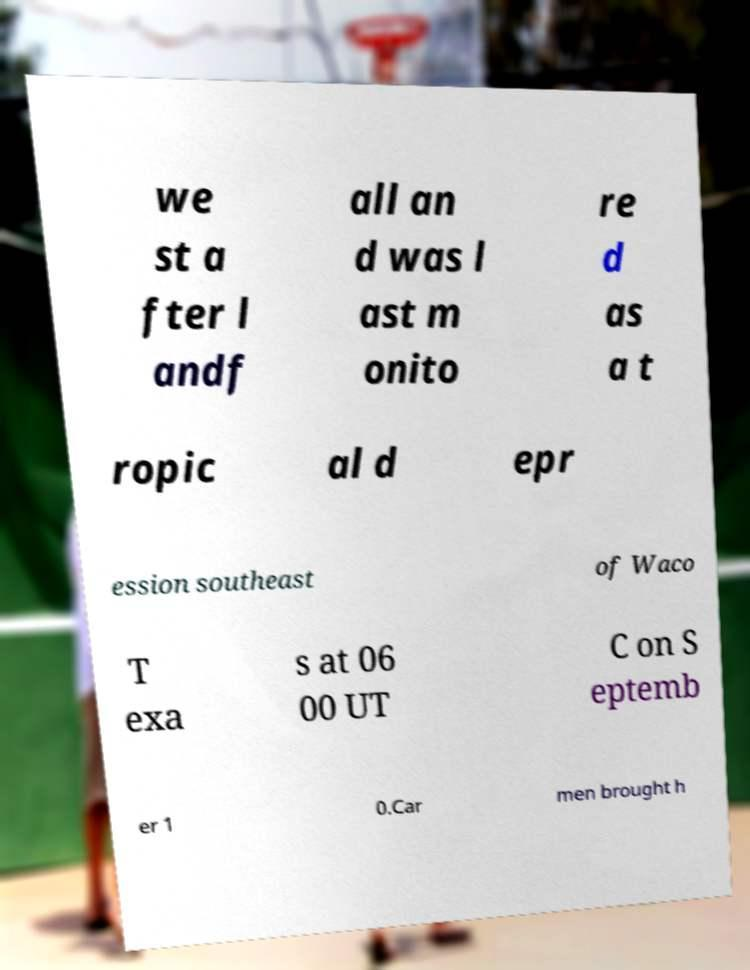Can you accurately transcribe the text from the provided image for me? we st a fter l andf all an d was l ast m onito re d as a t ropic al d epr ession southeast of Waco T exa s at 06 00 UT C on S eptemb er 1 0.Car men brought h 